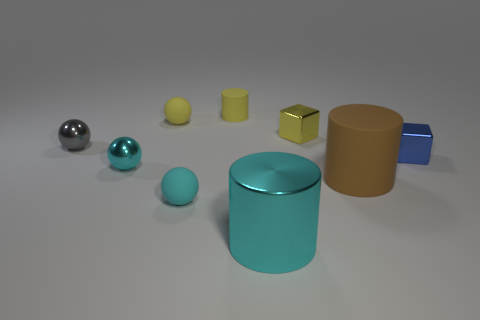Add 1 large gray cylinders. How many objects exist? 10 Subtract all spheres. How many objects are left? 5 Subtract 0 green balls. How many objects are left? 9 Subtract all green matte balls. Subtract all metallic spheres. How many objects are left? 7 Add 5 big cyan metal things. How many big cyan metal things are left? 6 Add 3 small brown things. How many small brown things exist? 3 